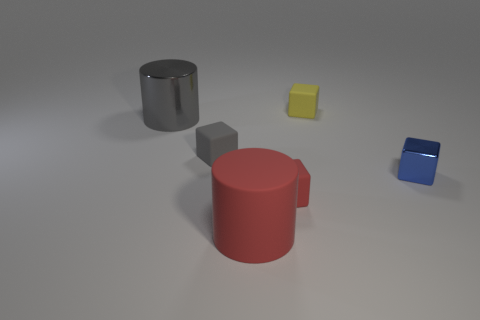Is the size of the red cylinder the same as the shiny cylinder?
Your answer should be compact. Yes. How many cubes are either gray objects or small rubber things?
Give a very brief answer. 3. How many small metal cubes are in front of the cylinder that is behind the blue metal thing?
Offer a terse response. 1. Is the shape of the tiny blue shiny thing the same as the tiny red rubber thing?
Provide a succinct answer. Yes. There is a metallic thing that is the same shape as the big matte thing; what is its size?
Offer a terse response. Large. What shape is the metallic object that is to the right of the large object that is to the left of the tiny gray rubber cube?
Offer a terse response. Cube. What size is the gray metallic cylinder?
Your response must be concise. Large. There is a blue metal object; what shape is it?
Give a very brief answer. Cube. There is a small red rubber object; is its shape the same as the large thing in front of the big gray cylinder?
Provide a short and direct response. No. Do the large thing that is on the right side of the large metallic object and the tiny gray object have the same shape?
Your answer should be compact. No. 